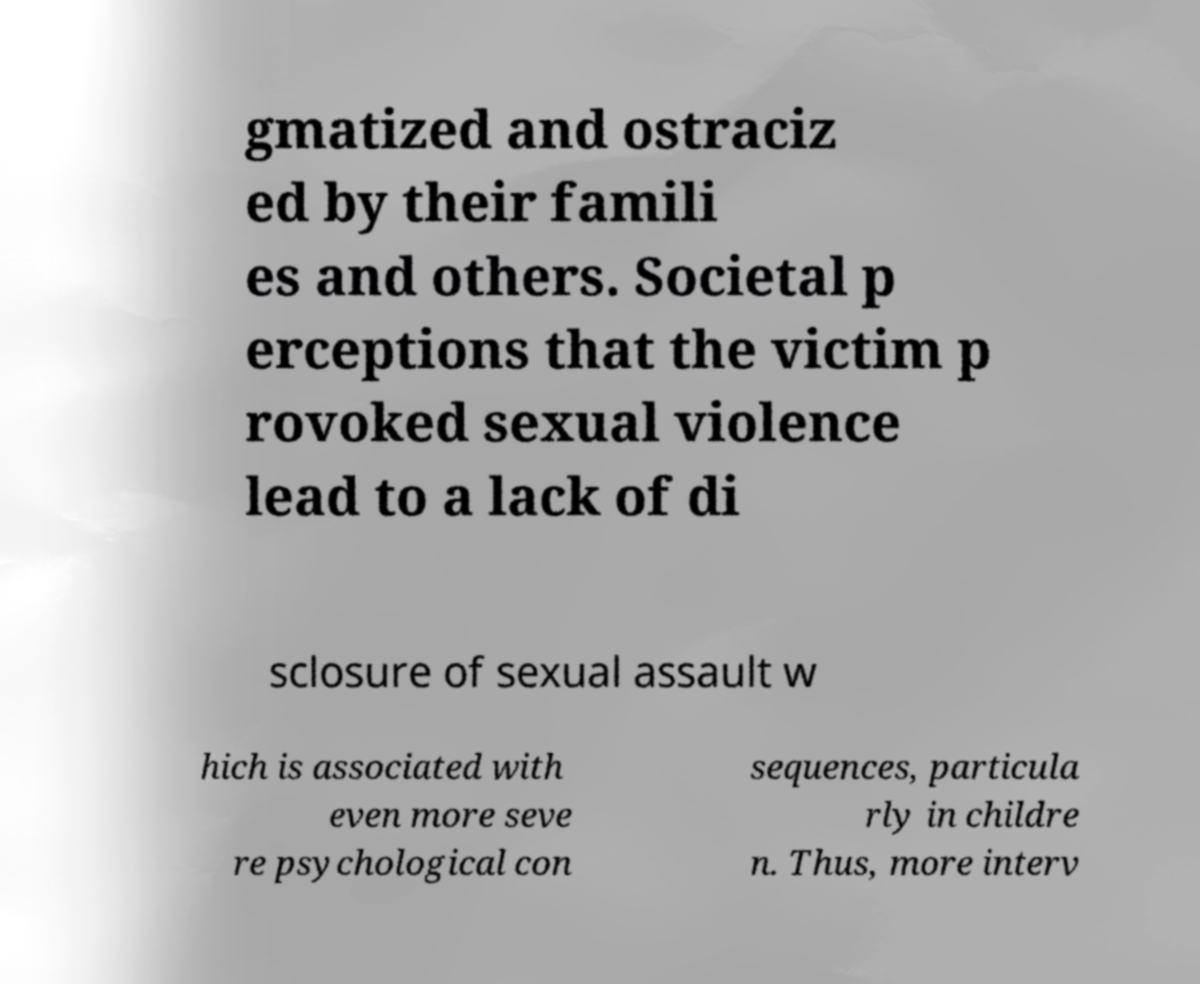There's text embedded in this image that I need extracted. Can you transcribe it verbatim? gmatized and ostraciz ed by their famili es and others. Societal p erceptions that the victim p rovoked sexual violence lead to a lack of di sclosure of sexual assault w hich is associated with even more seve re psychological con sequences, particula rly in childre n. Thus, more interv 